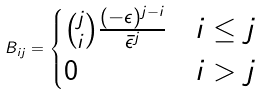Convert formula to latex. <formula><loc_0><loc_0><loc_500><loc_500>B _ { i j } = \begin{cases} \binom { j } { i } \frac { ( - \epsilon ) ^ { j - i } } { \bar { \epsilon } ^ { j } } & i \leq j \\ 0 & i > j \\ \end{cases}</formula> 